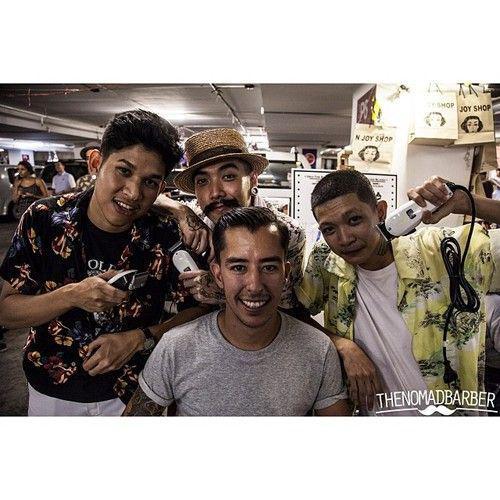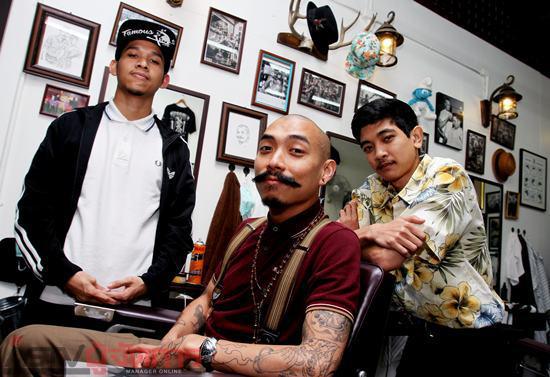The first image is the image on the left, the second image is the image on the right. Assess this claim about the two images: "There is exactly one person wearing a vest.". Correct or not? Answer yes or no. No. 